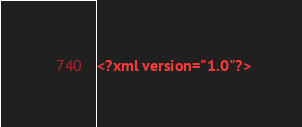<code> <loc_0><loc_0><loc_500><loc_500><_XML_><?xml version="1.0"?></code> 